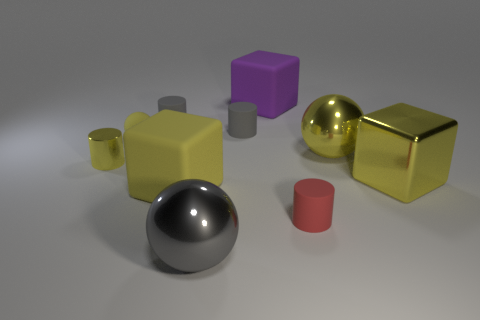Subtract all cubes. How many objects are left? 7 Subtract all big yellow shiny blocks. Subtract all cylinders. How many objects are left? 5 Add 3 yellow metal spheres. How many yellow metal spheres are left? 4 Add 7 tiny yellow cylinders. How many tiny yellow cylinders exist? 8 Subtract 0 green cylinders. How many objects are left? 10 